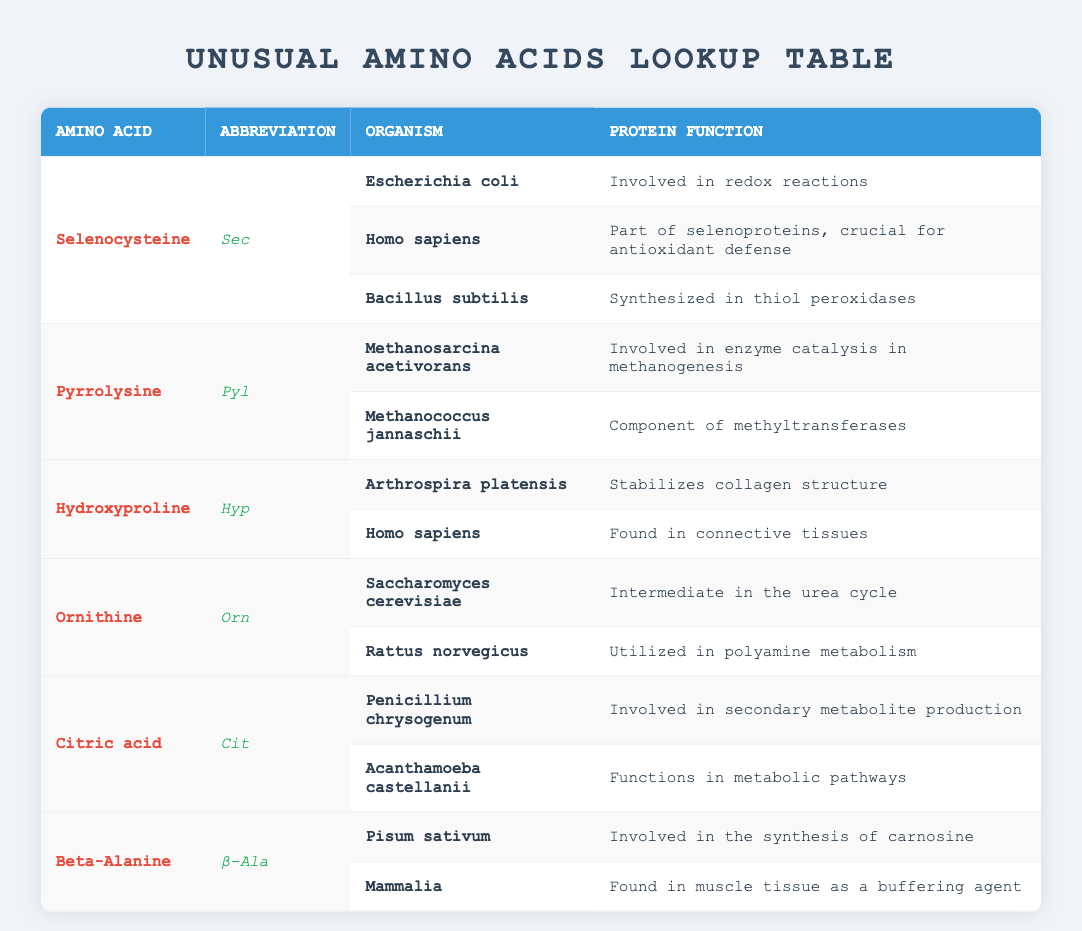What organisms contain Selenocysteine? The table lists three organisms associated with Selenocysteine: Escherichia coli, Homo sapiens, and Bacillus subtilis. Each organism is shown in the organism column corresponding to the protein function listed next to it.
Answer: Escherichia coli, Homo sapiens, Bacillus subtilis Which amino acid is involved in enzyme catalysis in methanogenesis? From the table, Pyrrolysine is identified as the amino acid involved in enzyme catalysis in methanogenesis, specifically in the organism Methanosarcina acetivorans. This fact can be found by looking at the row for Pyrrolysine and its associated organism.
Answer: Pyrrolysine How many organisms are listed for Hydroxyproline? Hydroxyproline is associated with two organisms, Arthrospira platensis and Homo sapiens, as indicated by the two entries for Hydroxyproline in the table.
Answer: 2 Is Beta-Alanine found in muscle tissue as a buffering agent? Yes, the table provides this information specifically under the Mammalia entry for Beta-Alanine, which states it is found in muscle tissue as a buffering agent. This confirms the fact presented by the table.
Answer: Yes Which unusual amino acid is involved in stabilizing collagen structure? The table shows Hydroxyproline is the amino acid involved in stabilizing collagen structure, specifically in the organism Arthrospira platensis, as noted in its corresponding row.
Answer: Hydroxyproline What is the protein function of Ornithine in Rattus norvegicus? The table specifies that Ornithine is utilized in polyamine metabolism in Rattus norvegicus. This detail can be found by locating the row for Ornithine and reading the related protein function.
Answer: Utilized in polyamine metabolism How many unique unusual amino acids are listed in the table? By counting each unique entry under the amino acid column, we find there are six distinct amino acids: Selenocysteine, Pyrrolysine, Hydroxyproline, Ornithine, Citric acid, and Beta-Alanine. Thus, the total is six.
Answer: 6 Which amino acid is synthesized in thiol peroxidases? According to the table, Selenocysteine is synthesized in thiol peroxidases as outlined in the row for Bacillus subtilis, which states its protein function clearly.
Answer: Selenocysteine What is the primary role of Citric acid in Acanthamoeba castellanii? The table reveals that Citric acid functions in metabolic pathways in Acanthamoeba castellanii, as indicated in its row under the protein function description.
Answer: Functions in metabolic pathways 